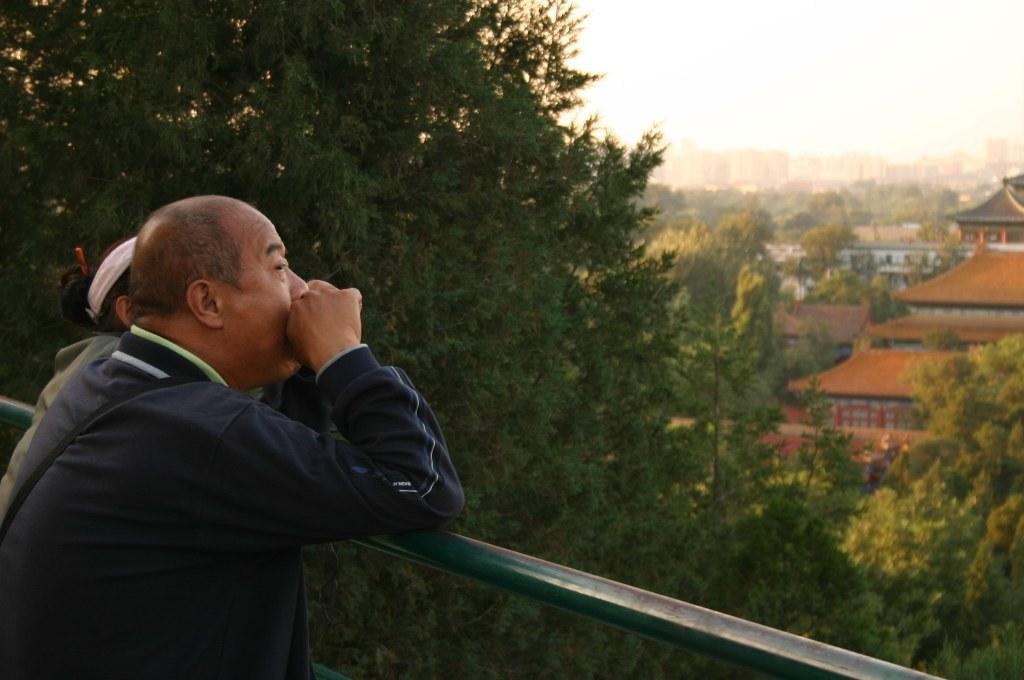Who are the people in the foreground of the image? There is a man and a woman in the foreground of the image. What are the man and woman doing in the image? Both the man and woman are standing near a railing. What can be seen in the background of the image? There are trees, buildings, and the sky visible in the background of the image. Is there a sandy beach visible in the image? No, there is no sandy beach present in the image. 